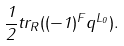<formula> <loc_0><loc_0><loc_500><loc_500>\frac { 1 } { 2 } t r _ { R } ( ( - 1 ) ^ { F } q ^ { L _ { 0 } } ) .</formula> 